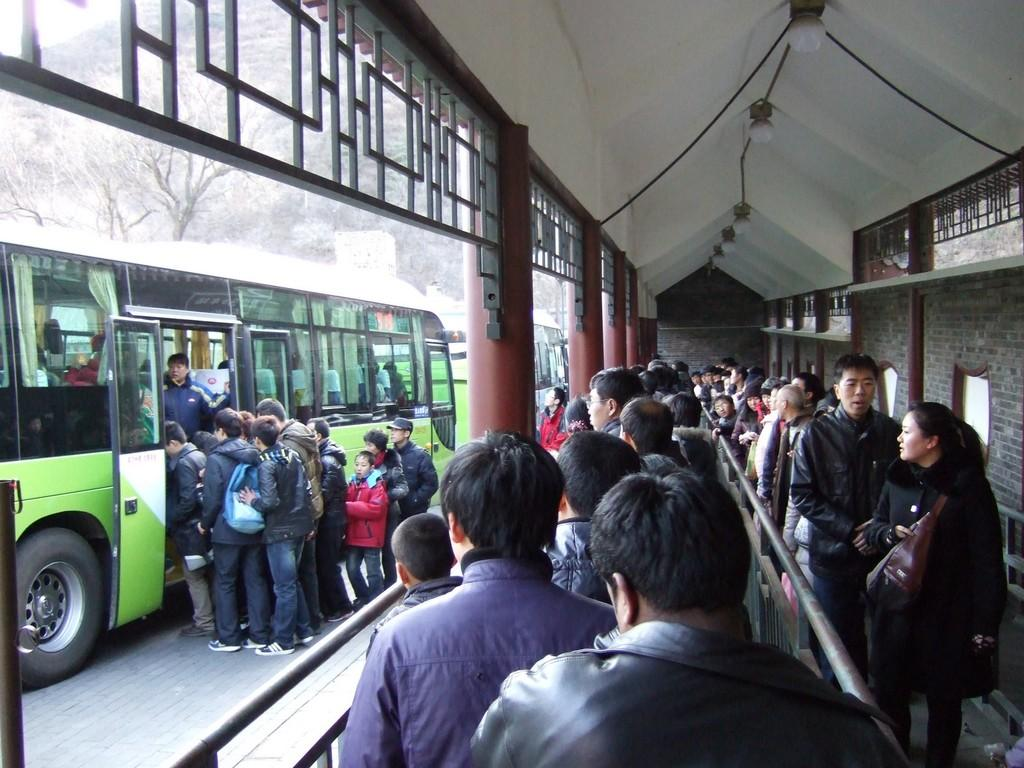What is located on the left side of the image? There is a bus on the left side of the image. What can be seen at the top of the image? There are trees and lights at the top of the image. What is present on the right side of the image? There are some persons on the right side of the image. What type of egg is being exchanged between the persons in the image? There is no egg present in the image, nor is there any indication of an exchange between the persons. 